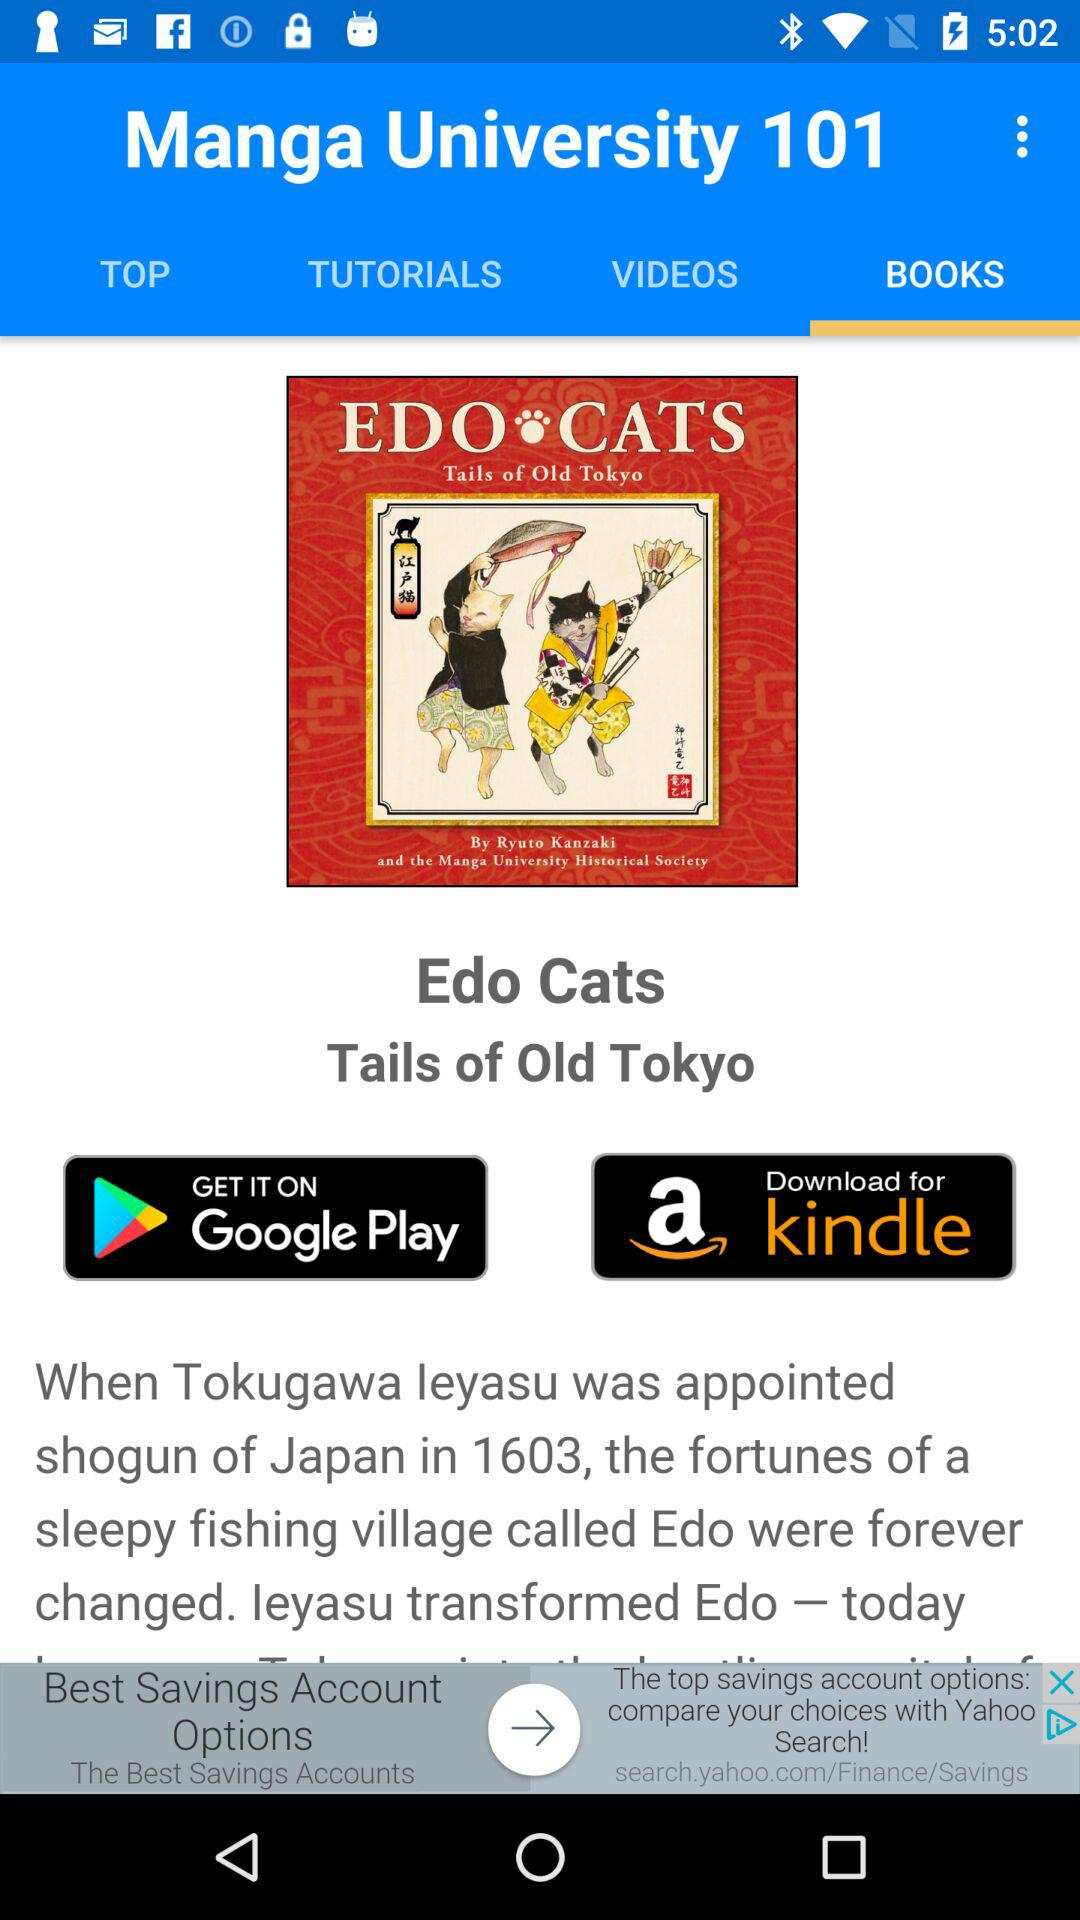Where can I get it? You can get it on Google Play. 